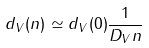Convert formula to latex. <formula><loc_0><loc_0><loc_500><loc_500>d _ { V } ( n ) \simeq d _ { V } ( 0 ) \frac { 1 } { D _ { V } n }</formula> 